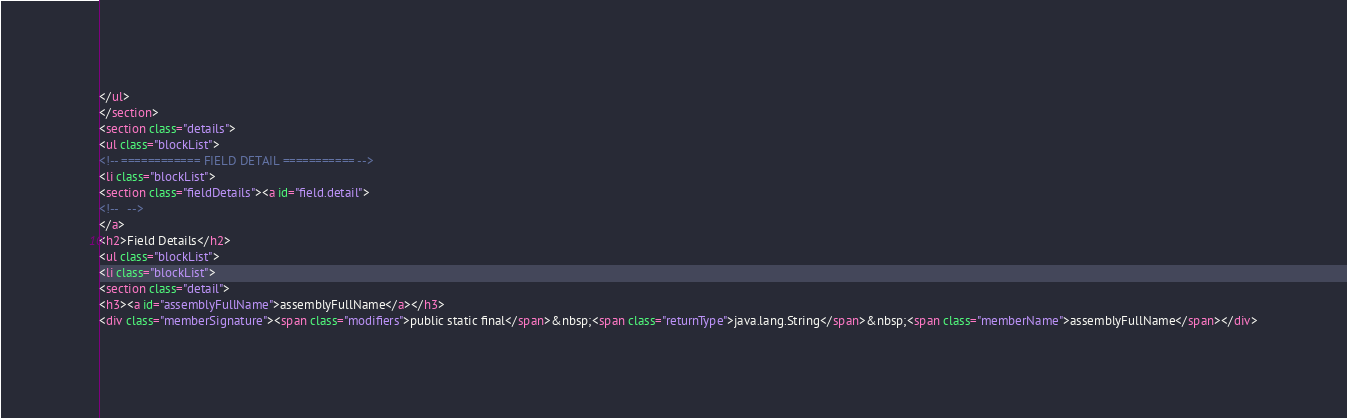Convert code to text. <code><loc_0><loc_0><loc_500><loc_500><_HTML_></ul>
</section>
<section class="details">
<ul class="blockList">
<!-- ============ FIELD DETAIL =========== -->
<li class="blockList">
<section class="fieldDetails"><a id="field.detail">
<!--   -->
</a>
<h2>Field Details</h2>
<ul class="blockList">
<li class="blockList">
<section class="detail">
<h3><a id="assemblyFullName">assemblyFullName</a></h3>
<div class="memberSignature"><span class="modifiers">public static final</span>&nbsp;<span class="returnType">java.lang.String</span>&nbsp;<span class="memberName">assemblyFullName</span></div></code> 